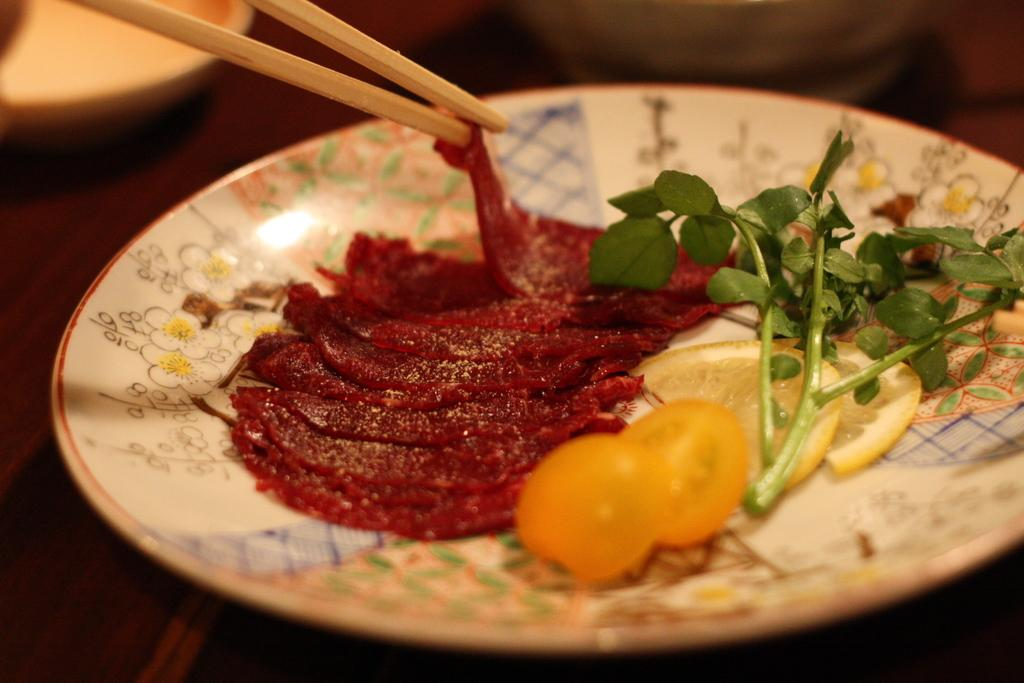What is on the plate that is visible in the image? There is food on the plate in the image. What utensils are present in the image? There are two chopsticks in the image. Where is the plate located in the image? The plate is placed on a table in the image. Can you see your sister in the image? There is no mention of a sister or any people in the image, so it cannot be determined if your sister is present. 